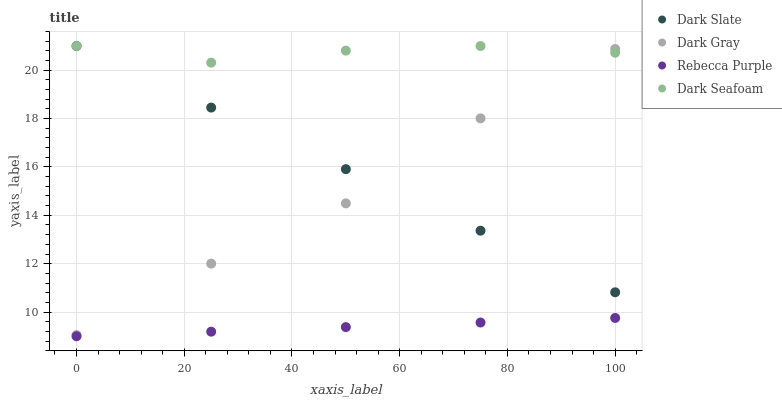Does Rebecca Purple have the minimum area under the curve?
Answer yes or no. Yes. Does Dark Seafoam have the maximum area under the curve?
Answer yes or no. Yes. Does Dark Slate have the minimum area under the curve?
Answer yes or no. No. Does Dark Slate have the maximum area under the curve?
Answer yes or no. No. Is Rebecca Purple the smoothest?
Answer yes or no. Yes. Is Dark Gray the roughest?
Answer yes or no. Yes. Is Dark Slate the smoothest?
Answer yes or no. No. Is Dark Slate the roughest?
Answer yes or no. No. Does Rebecca Purple have the lowest value?
Answer yes or no. Yes. Does Dark Slate have the lowest value?
Answer yes or no. No. Does Dark Seafoam have the highest value?
Answer yes or no. Yes. Does Rebecca Purple have the highest value?
Answer yes or no. No. Is Rebecca Purple less than Dark Seafoam?
Answer yes or no. Yes. Is Dark Slate greater than Rebecca Purple?
Answer yes or no. Yes. Does Dark Seafoam intersect Dark Slate?
Answer yes or no. Yes. Is Dark Seafoam less than Dark Slate?
Answer yes or no. No. Is Dark Seafoam greater than Dark Slate?
Answer yes or no. No. Does Rebecca Purple intersect Dark Seafoam?
Answer yes or no. No. 